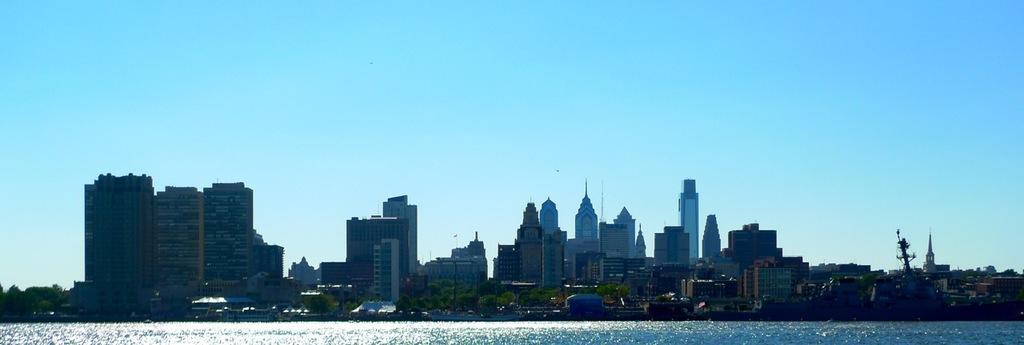Could you give a brief overview of what you see in this image? In this image I can see the water. In the background I can see few trees in green color, buildings, light poles and the sky is in blue color. 